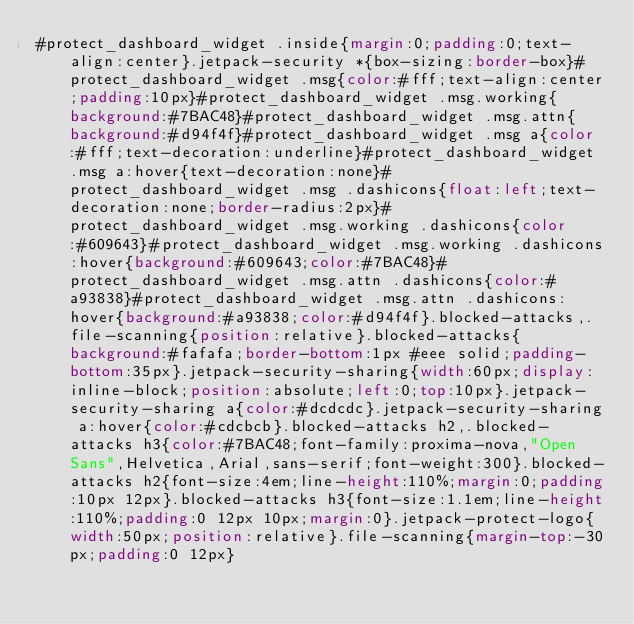Convert code to text. <code><loc_0><loc_0><loc_500><loc_500><_CSS_>#protect_dashboard_widget .inside{margin:0;padding:0;text-align:center}.jetpack-security *{box-sizing:border-box}#protect_dashboard_widget .msg{color:#fff;text-align:center;padding:10px}#protect_dashboard_widget .msg.working{background:#7BAC48}#protect_dashboard_widget .msg.attn{background:#d94f4f}#protect_dashboard_widget .msg a{color:#fff;text-decoration:underline}#protect_dashboard_widget .msg a:hover{text-decoration:none}#protect_dashboard_widget .msg .dashicons{float:left;text-decoration:none;border-radius:2px}#protect_dashboard_widget .msg.working .dashicons{color:#609643}#protect_dashboard_widget .msg.working .dashicons:hover{background:#609643;color:#7BAC48}#protect_dashboard_widget .msg.attn .dashicons{color:#a93838}#protect_dashboard_widget .msg.attn .dashicons:hover{background:#a93838;color:#d94f4f}.blocked-attacks,.file-scanning{position:relative}.blocked-attacks{background:#fafafa;border-bottom:1px #eee solid;padding-bottom:35px}.jetpack-security-sharing{width:60px;display:inline-block;position:absolute;left:0;top:10px}.jetpack-security-sharing a{color:#dcdcdc}.jetpack-security-sharing a:hover{color:#cdcbcb}.blocked-attacks h2,.blocked-attacks h3{color:#7BAC48;font-family:proxima-nova,"Open Sans",Helvetica,Arial,sans-serif;font-weight:300}.blocked-attacks h2{font-size:4em;line-height:110%;margin:0;padding:10px 12px}.blocked-attacks h3{font-size:1.1em;line-height:110%;padding:0 12px 10px;margin:0}.jetpack-protect-logo{width:50px;position:relative}.file-scanning{margin-top:-30px;padding:0 12px}</code> 